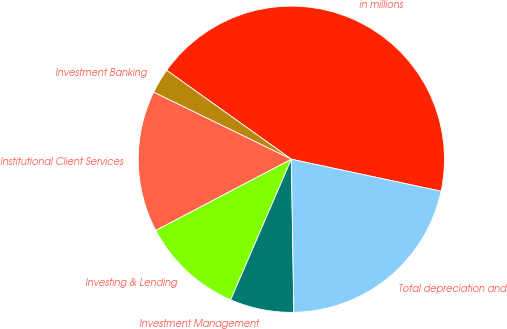<chart> <loc_0><loc_0><loc_500><loc_500><pie_chart><fcel>in millions<fcel>Investment Banking<fcel>Institutional Client Services<fcel>Investing & Lending<fcel>Investment Management<fcel>Total depreciation and<nl><fcel>43.49%<fcel>2.65%<fcel>14.91%<fcel>10.82%<fcel>6.74%<fcel>21.39%<nl></chart> 